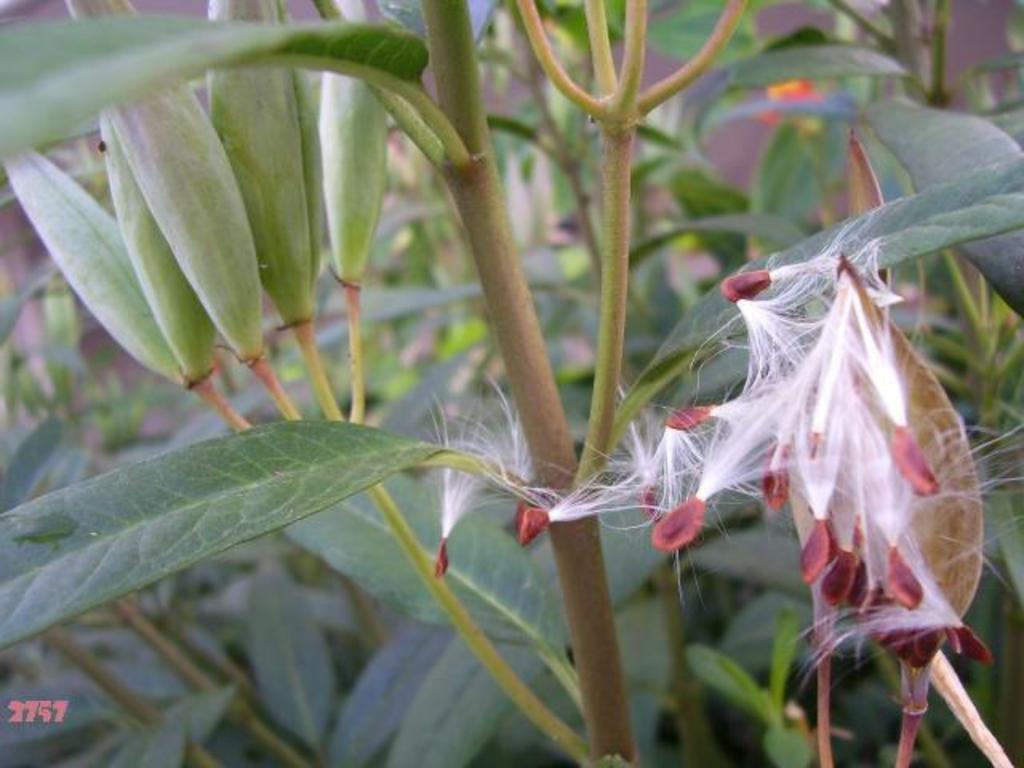How would you summarize this image in a sentence or two? In the foreground of this image, there are weed cotton to the plants. In the background, there are plants. 